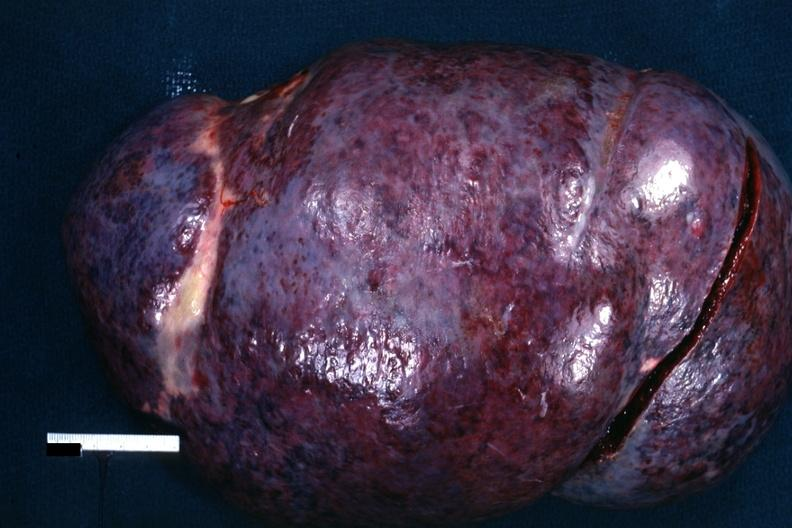does chest and abdomen slide show external view of massively enlarged spleen with purple color?
Answer the question using a single word or phrase. No 